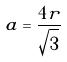Convert formula to latex. <formula><loc_0><loc_0><loc_500><loc_500>a = \frac { 4 r } { \sqrt { 3 } }</formula> 